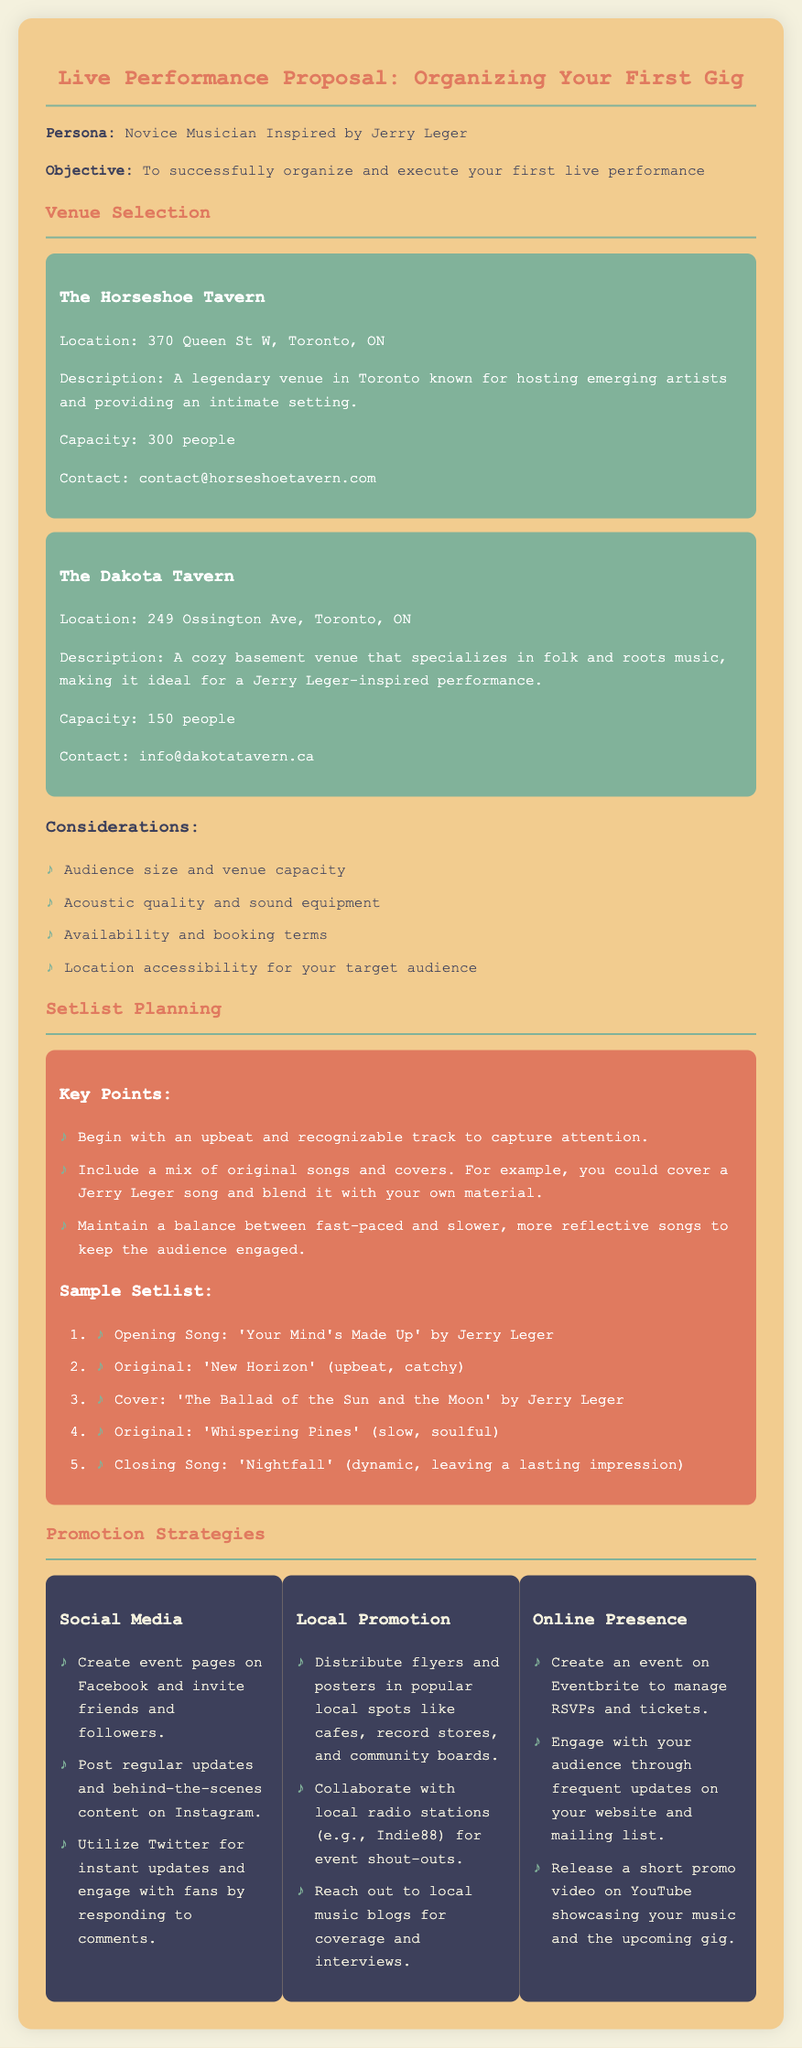What is the name of the first venue listed? The first venue listed in the document is The Horseshoe Tavern.
Answer: The Horseshoe Tavern What is the maximum capacity of The Dakota Tavern? The Dakota Tavern has a capacity of 150 people, as stated in the venue description.
Answer: 150 people Which song is suggested to open the setlist? The proposal recommends starting with 'Your Mind's Made Up' by Jerry Leger as the opening song.
Answer: 'Your Mind's Made Up' What social media platform is mentioned for creating event pages? The document specifies using Facebook to create event pages and invite friends.
Answer: Facebook What type of music is The Dakota Tavern known for? The Dakota Tavern specializes in folk and roots music according to the document's description.
Answer: Folk and roots music How many promotional strategies are listed in the document? The document lists three promotional strategies: Social Media, Local Promotion, and Online Presence.
Answer: Three What is the address of The Horseshoe Tavern? The address for The Horseshoe Tavern is 370 Queen St W, Toronto, ON, mentioned in the venue information.
Answer: 370 Queen St W, Toronto, ON Which song in the setlist is described as "slow, soulful"? The song 'Whispering Pines' is indicated as slow and soulful in the sample setlist section.
Answer: 'Whispering Pines' What is the contact email for The Dakota Tavern? The contact email for The Dakota Tavern is info@dakotatavern.ca, listed in the venue details.
Answer: info@dakotatavern.ca 